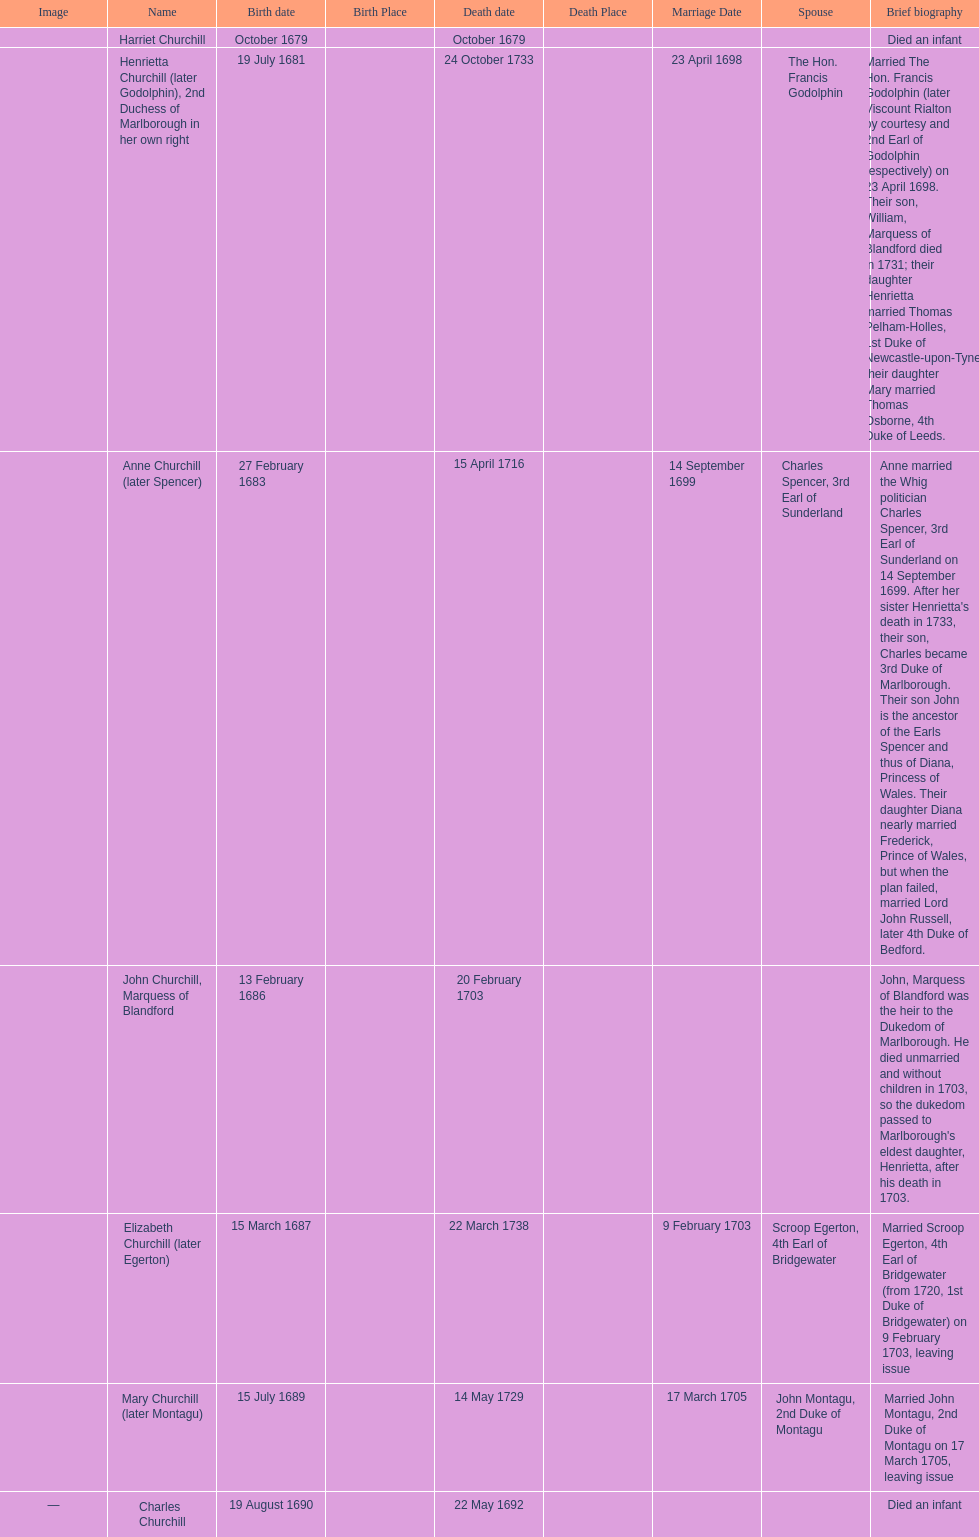What was the birthdate of sarah churchill's first child? October 1679. 